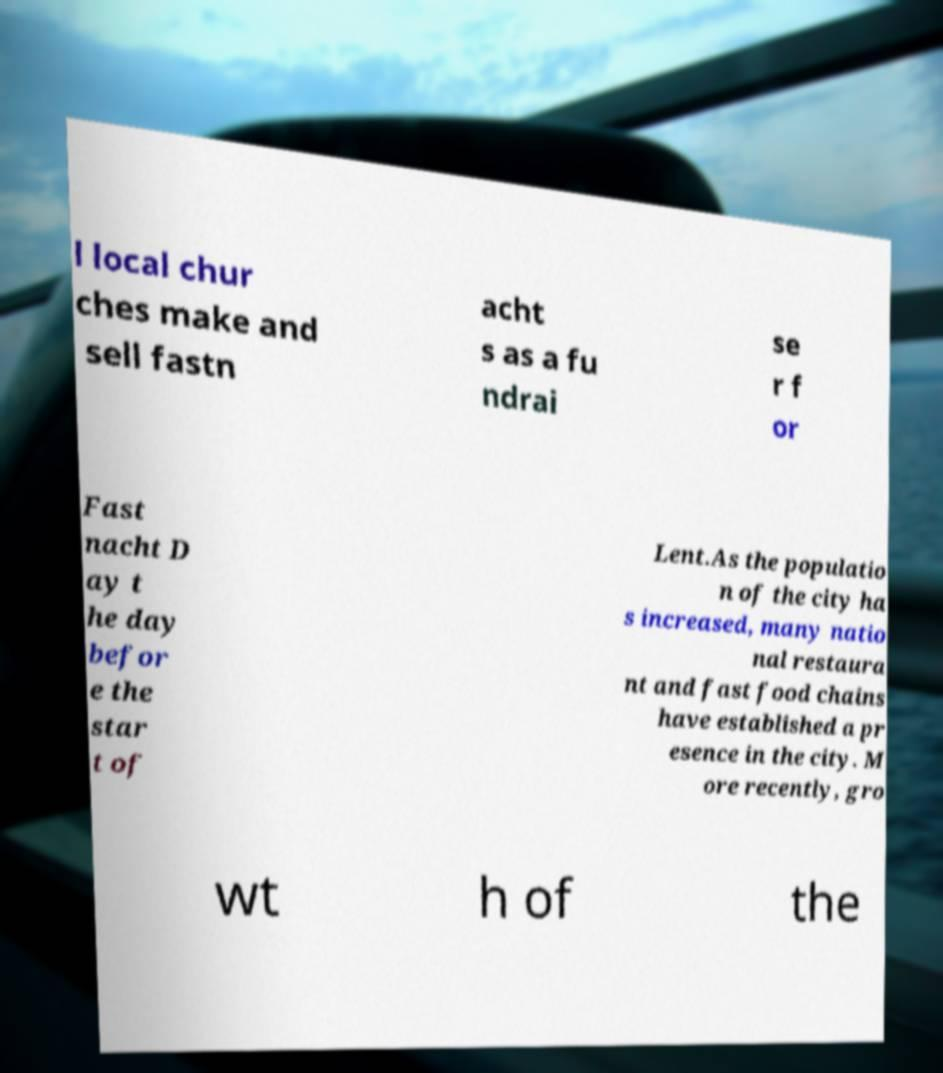Could you extract and type out the text from this image? l local chur ches make and sell fastn acht s as a fu ndrai se r f or Fast nacht D ay t he day befor e the star t of Lent.As the populatio n of the city ha s increased, many natio nal restaura nt and fast food chains have established a pr esence in the city. M ore recently, gro wt h of the 